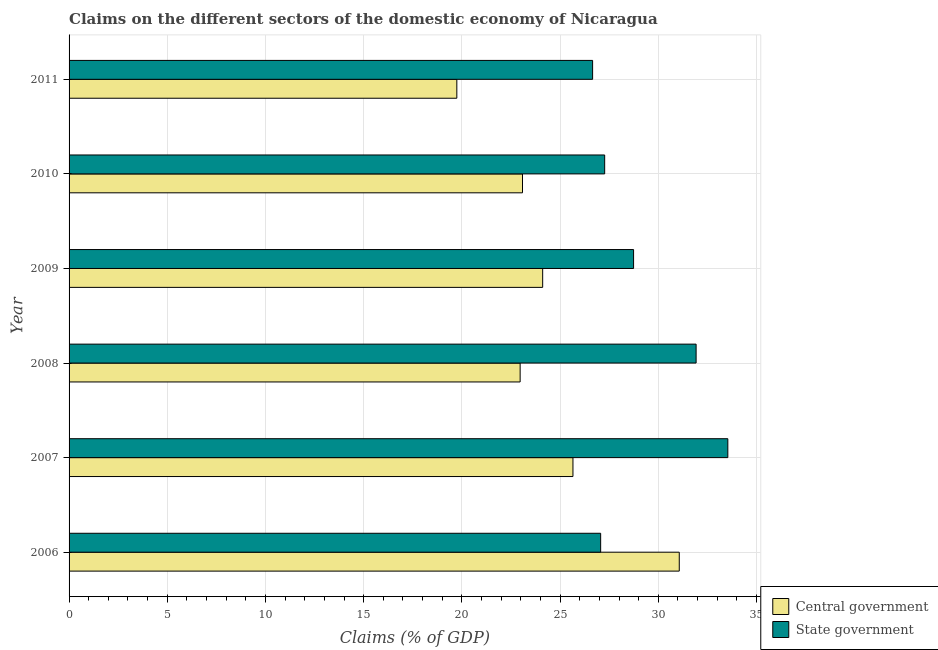How many different coloured bars are there?
Offer a terse response. 2. Are the number of bars per tick equal to the number of legend labels?
Your response must be concise. Yes. Are the number of bars on each tick of the Y-axis equal?
Your response must be concise. Yes. How many bars are there on the 4th tick from the bottom?
Offer a very short reply. 2. What is the label of the 5th group of bars from the top?
Offer a terse response. 2007. What is the claims on state government in 2011?
Give a very brief answer. 26.66. Across all years, what is the maximum claims on state government?
Your answer should be compact. 33.54. Across all years, what is the minimum claims on central government?
Offer a terse response. 19.74. In which year was the claims on central government maximum?
Give a very brief answer. 2006. What is the total claims on state government in the graph?
Your answer should be very brief. 175.2. What is the difference between the claims on state government in 2009 and that in 2011?
Offer a very short reply. 2.09. What is the difference between the claims on central government in 2008 and the claims on state government in 2006?
Provide a short and direct response. -4.1. What is the average claims on central government per year?
Your answer should be compact. 24.44. In the year 2009, what is the difference between the claims on state government and claims on central government?
Offer a terse response. 4.63. In how many years, is the claims on state government greater than 13 %?
Provide a short and direct response. 6. What is the ratio of the claims on state government in 2009 to that in 2010?
Make the answer very short. 1.05. Is the claims on central government in 2006 less than that in 2008?
Offer a terse response. No. Is the difference between the claims on central government in 2006 and 2011 greater than the difference between the claims on state government in 2006 and 2011?
Keep it short and to the point. Yes. What is the difference between the highest and the second highest claims on central government?
Give a very brief answer. 5.41. What is the difference between the highest and the lowest claims on state government?
Ensure brevity in your answer.  6.88. In how many years, is the claims on state government greater than the average claims on state government taken over all years?
Offer a very short reply. 2. Is the sum of the claims on state government in 2006 and 2008 greater than the maximum claims on central government across all years?
Make the answer very short. Yes. What does the 2nd bar from the top in 2010 represents?
Ensure brevity in your answer.  Central government. What does the 1st bar from the bottom in 2010 represents?
Your answer should be very brief. Central government. How many bars are there?
Give a very brief answer. 12. What is the difference between two consecutive major ticks on the X-axis?
Offer a terse response. 5. Are the values on the major ticks of X-axis written in scientific E-notation?
Your answer should be compact. No. Does the graph contain any zero values?
Offer a terse response. No. What is the title of the graph?
Make the answer very short. Claims on the different sectors of the domestic economy of Nicaragua. What is the label or title of the X-axis?
Offer a very short reply. Claims (% of GDP). What is the label or title of the Y-axis?
Provide a short and direct response. Year. What is the Claims (% of GDP) of Central government in 2006?
Provide a short and direct response. 31.07. What is the Claims (% of GDP) of State government in 2006?
Offer a terse response. 27.07. What is the Claims (% of GDP) of Central government in 2007?
Offer a very short reply. 25.66. What is the Claims (% of GDP) of State government in 2007?
Your answer should be compact. 33.54. What is the Claims (% of GDP) of Central government in 2008?
Your response must be concise. 22.97. What is the Claims (% of GDP) in State government in 2008?
Your response must be concise. 31.93. What is the Claims (% of GDP) in Central government in 2009?
Make the answer very short. 24.11. What is the Claims (% of GDP) in State government in 2009?
Provide a short and direct response. 28.74. What is the Claims (% of GDP) of Central government in 2010?
Ensure brevity in your answer.  23.09. What is the Claims (% of GDP) of State government in 2010?
Your answer should be very brief. 27.27. What is the Claims (% of GDP) of Central government in 2011?
Provide a short and direct response. 19.74. What is the Claims (% of GDP) in State government in 2011?
Provide a succinct answer. 26.66. Across all years, what is the maximum Claims (% of GDP) in Central government?
Your answer should be very brief. 31.07. Across all years, what is the maximum Claims (% of GDP) in State government?
Provide a short and direct response. 33.54. Across all years, what is the minimum Claims (% of GDP) in Central government?
Your response must be concise. 19.74. Across all years, what is the minimum Claims (% of GDP) in State government?
Keep it short and to the point. 26.66. What is the total Claims (% of GDP) in Central government in the graph?
Your answer should be compact. 146.64. What is the total Claims (% of GDP) in State government in the graph?
Offer a very short reply. 175.2. What is the difference between the Claims (% of GDP) of Central government in 2006 and that in 2007?
Provide a succinct answer. 5.41. What is the difference between the Claims (% of GDP) in State government in 2006 and that in 2007?
Ensure brevity in your answer.  -6.47. What is the difference between the Claims (% of GDP) of Central government in 2006 and that in 2008?
Provide a succinct answer. 8.1. What is the difference between the Claims (% of GDP) in State government in 2006 and that in 2008?
Your answer should be compact. -4.86. What is the difference between the Claims (% of GDP) in Central government in 2006 and that in 2009?
Your response must be concise. 6.96. What is the difference between the Claims (% of GDP) in State government in 2006 and that in 2009?
Make the answer very short. -1.68. What is the difference between the Claims (% of GDP) of Central government in 2006 and that in 2010?
Make the answer very short. 7.98. What is the difference between the Claims (% of GDP) in State government in 2006 and that in 2010?
Make the answer very short. -0.2. What is the difference between the Claims (% of GDP) in Central government in 2006 and that in 2011?
Ensure brevity in your answer.  11.33. What is the difference between the Claims (% of GDP) in State government in 2006 and that in 2011?
Your answer should be compact. 0.41. What is the difference between the Claims (% of GDP) in Central government in 2007 and that in 2008?
Your answer should be very brief. 2.69. What is the difference between the Claims (% of GDP) in State government in 2007 and that in 2008?
Your answer should be very brief. 1.61. What is the difference between the Claims (% of GDP) in Central government in 2007 and that in 2009?
Your answer should be compact. 1.54. What is the difference between the Claims (% of GDP) of State government in 2007 and that in 2009?
Ensure brevity in your answer.  4.8. What is the difference between the Claims (% of GDP) of Central government in 2007 and that in 2010?
Your response must be concise. 2.57. What is the difference between the Claims (% of GDP) of State government in 2007 and that in 2010?
Give a very brief answer. 6.27. What is the difference between the Claims (% of GDP) of Central government in 2007 and that in 2011?
Make the answer very short. 5.91. What is the difference between the Claims (% of GDP) in State government in 2007 and that in 2011?
Your answer should be very brief. 6.88. What is the difference between the Claims (% of GDP) of Central government in 2008 and that in 2009?
Offer a terse response. -1.15. What is the difference between the Claims (% of GDP) of State government in 2008 and that in 2009?
Provide a short and direct response. 3.18. What is the difference between the Claims (% of GDP) of Central government in 2008 and that in 2010?
Offer a terse response. -0.12. What is the difference between the Claims (% of GDP) in State government in 2008 and that in 2010?
Offer a very short reply. 4.66. What is the difference between the Claims (% of GDP) of Central government in 2008 and that in 2011?
Ensure brevity in your answer.  3.22. What is the difference between the Claims (% of GDP) of State government in 2008 and that in 2011?
Provide a succinct answer. 5.27. What is the difference between the Claims (% of GDP) of Central government in 2009 and that in 2010?
Provide a short and direct response. 1.03. What is the difference between the Claims (% of GDP) in State government in 2009 and that in 2010?
Offer a terse response. 1.47. What is the difference between the Claims (% of GDP) in Central government in 2009 and that in 2011?
Your response must be concise. 4.37. What is the difference between the Claims (% of GDP) in State government in 2009 and that in 2011?
Ensure brevity in your answer.  2.09. What is the difference between the Claims (% of GDP) of Central government in 2010 and that in 2011?
Offer a very short reply. 3.34. What is the difference between the Claims (% of GDP) in State government in 2010 and that in 2011?
Offer a very short reply. 0.61. What is the difference between the Claims (% of GDP) of Central government in 2006 and the Claims (% of GDP) of State government in 2007?
Give a very brief answer. -2.47. What is the difference between the Claims (% of GDP) in Central government in 2006 and the Claims (% of GDP) in State government in 2008?
Your answer should be very brief. -0.86. What is the difference between the Claims (% of GDP) of Central government in 2006 and the Claims (% of GDP) of State government in 2009?
Keep it short and to the point. 2.33. What is the difference between the Claims (% of GDP) of Central government in 2006 and the Claims (% of GDP) of State government in 2010?
Keep it short and to the point. 3.8. What is the difference between the Claims (% of GDP) of Central government in 2006 and the Claims (% of GDP) of State government in 2011?
Make the answer very short. 4.41. What is the difference between the Claims (% of GDP) of Central government in 2007 and the Claims (% of GDP) of State government in 2008?
Make the answer very short. -6.27. What is the difference between the Claims (% of GDP) of Central government in 2007 and the Claims (% of GDP) of State government in 2009?
Offer a terse response. -3.09. What is the difference between the Claims (% of GDP) of Central government in 2007 and the Claims (% of GDP) of State government in 2010?
Offer a very short reply. -1.61. What is the difference between the Claims (% of GDP) in Central government in 2007 and the Claims (% of GDP) in State government in 2011?
Ensure brevity in your answer.  -1. What is the difference between the Claims (% of GDP) of Central government in 2008 and the Claims (% of GDP) of State government in 2009?
Offer a terse response. -5.78. What is the difference between the Claims (% of GDP) of Central government in 2008 and the Claims (% of GDP) of State government in 2010?
Offer a very short reply. -4.3. What is the difference between the Claims (% of GDP) of Central government in 2008 and the Claims (% of GDP) of State government in 2011?
Make the answer very short. -3.69. What is the difference between the Claims (% of GDP) of Central government in 2009 and the Claims (% of GDP) of State government in 2010?
Your response must be concise. -3.16. What is the difference between the Claims (% of GDP) in Central government in 2009 and the Claims (% of GDP) in State government in 2011?
Give a very brief answer. -2.54. What is the difference between the Claims (% of GDP) of Central government in 2010 and the Claims (% of GDP) of State government in 2011?
Offer a very short reply. -3.57. What is the average Claims (% of GDP) in Central government per year?
Provide a short and direct response. 24.44. What is the average Claims (% of GDP) of State government per year?
Your answer should be very brief. 29.2. In the year 2006, what is the difference between the Claims (% of GDP) of Central government and Claims (% of GDP) of State government?
Make the answer very short. 4. In the year 2007, what is the difference between the Claims (% of GDP) of Central government and Claims (% of GDP) of State government?
Offer a very short reply. -7.88. In the year 2008, what is the difference between the Claims (% of GDP) of Central government and Claims (% of GDP) of State government?
Give a very brief answer. -8.96. In the year 2009, what is the difference between the Claims (% of GDP) of Central government and Claims (% of GDP) of State government?
Your answer should be very brief. -4.63. In the year 2010, what is the difference between the Claims (% of GDP) in Central government and Claims (% of GDP) in State government?
Your answer should be compact. -4.18. In the year 2011, what is the difference between the Claims (% of GDP) in Central government and Claims (% of GDP) in State government?
Give a very brief answer. -6.91. What is the ratio of the Claims (% of GDP) in Central government in 2006 to that in 2007?
Keep it short and to the point. 1.21. What is the ratio of the Claims (% of GDP) of State government in 2006 to that in 2007?
Keep it short and to the point. 0.81. What is the ratio of the Claims (% of GDP) in Central government in 2006 to that in 2008?
Make the answer very short. 1.35. What is the ratio of the Claims (% of GDP) in State government in 2006 to that in 2008?
Provide a short and direct response. 0.85. What is the ratio of the Claims (% of GDP) in Central government in 2006 to that in 2009?
Give a very brief answer. 1.29. What is the ratio of the Claims (% of GDP) of State government in 2006 to that in 2009?
Make the answer very short. 0.94. What is the ratio of the Claims (% of GDP) of Central government in 2006 to that in 2010?
Give a very brief answer. 1.35. What is the ratio of the Claims (% of GDP) of Central government in 2006 to that in 2011?
Keep it short and to the point. 1.57. What is the ratio of the Claims (% of GDP) in State government in 2006 to that in 2011?
Provide a succinct answer. 1.02. What is the ratio of the Claims (% of GDP) of Central government in 2007 to that in 2008?
Ensure brevity in your answer.  1.12. What is the ratio of the Claims (% of GDP) of State government in 2007 to that in 2008?
Provide a succinct answer. 1.05. What is the ratio of the Claims (% of GDP) of Central government in 2007 to that in 2009?
Keep it short and to the point. 1.06. What is the ratio of the Claims (% of GDP) of State government in 2007 to that in 2009?
Provide a succinct answer. 1.17. What is the ratio of the Claims (% of GDP) in Central government in 2007 to that in 2010?
Give a very brief answer. 1.11. What is the ratio of the Claims (% of GDP) in State government in 2007 to that in 2010?
Keep it short and to the point. 1.23. What is the ratio of the Claims (% of GDP) of Central government in 2007 to that in 2011?
Your answer should be very brief. 1.3. What is the ratio of the Claims (% of GDP) in State government in 2007 to that in 2011?
Give a very brief answer. 1.26. What is the ratio of the Claims (% of GDP) in State government in 2008 to that in 2009?
Provide a short and direct response. 1.11. What is the ratio of the Claims (% of GDP) of State government in 2008 to that in 2010?
Your answer should be very brief. 1.17. What is the ratio of the Claims (% of GDP) of Central government in 2008 to that in 2011?
Provide a short and direct response. 1.16. What is the ratio of the Claims (% of GDP) of State government in 2008 to that in 2011?
Make the answer very short. 1.2. What is the ratio of the Claims (% of GDP) in Central government in 2009 to that in 2010?
Your answer should be very brief. 1.04. What is the ratio of the Claims (% of GDP) of State government in 2009 to that in 2010?
Keep it short and to the point. 1.05. What is the ratio of the Claims (% of GDP) of Central government in 2009 to that in 2011?
Your response must be concise. 1.22. What is the ratio of the Claims (% of GDP) in State government in 2009 to that in 2011?
Your answer should be compact. 1.08. What is the ratio of the Claims (% of GDP) in Central government in 2010 to that in 2011?
Offer a very short reply. 1.17. What is the difference between the highest and the second highest Claims (% of GDP) of Central government?
Your answer should be compact. 5.41. What is the difference between the highest and the second highest Claims (% of GDP) in State government?
Your answer should be compact. 1.61. What is the difference between the highest and the lowest Claims (% of GDP) in Central government?
Give a very brief answer. 11.33. What is the difference between the highest and the lowest Claims (% of GDP) of State government?
Your answer should be compact. 6.88. 